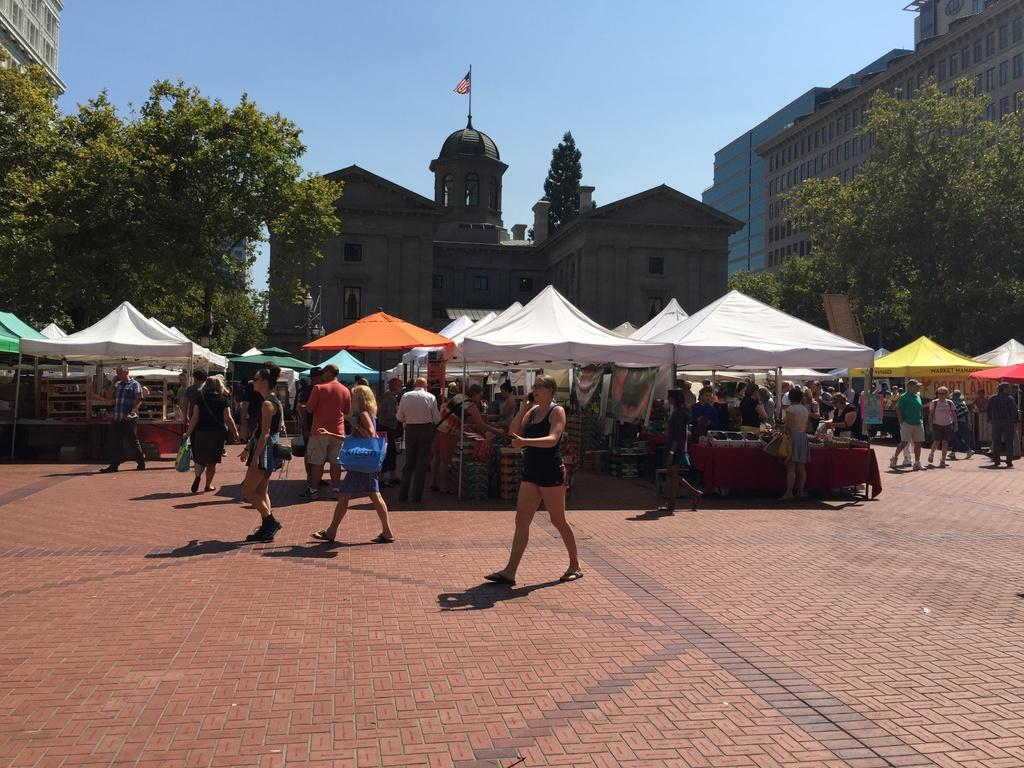What are the people in the image doing? The people in the image are walking on the road. What structures can be seen in the image? There are tents, stalls, and buildings in the image. What type of vegetation is present in the image? There are trees in the image. What is the color of the sky in the background? The sky in the background is a plain blue color. Can you see the arm of the cat in the image? There is no cat present in the image, so it is not possible to see the arm of a cat. 